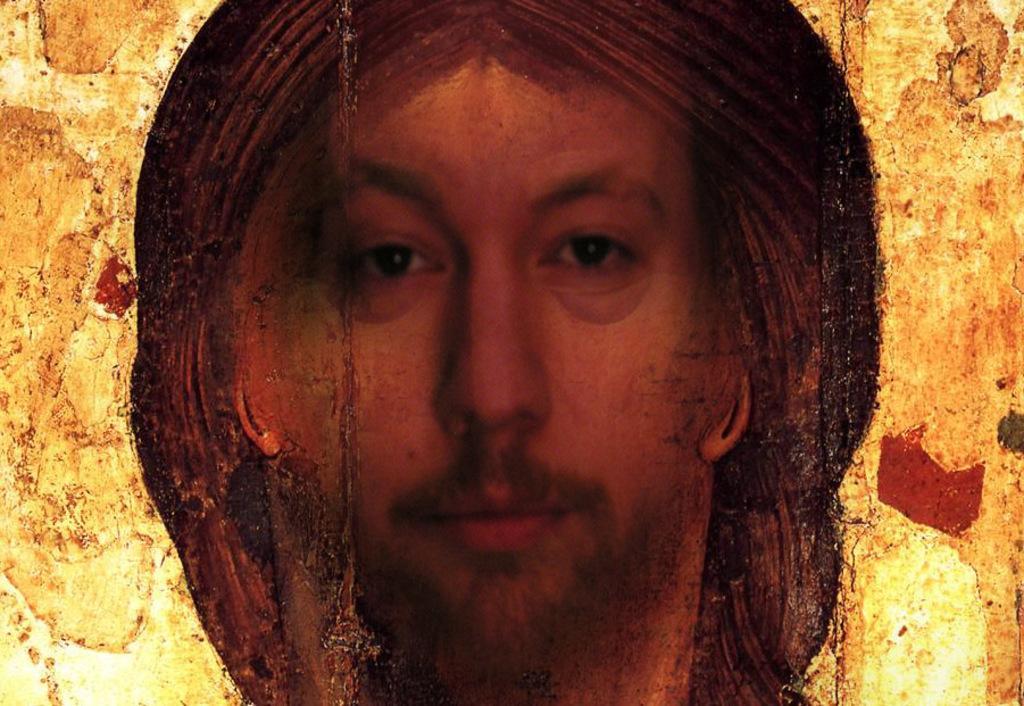In one or two sentences, can you explain what this image depicts? In this image we can see the painting of a person on a wall. 